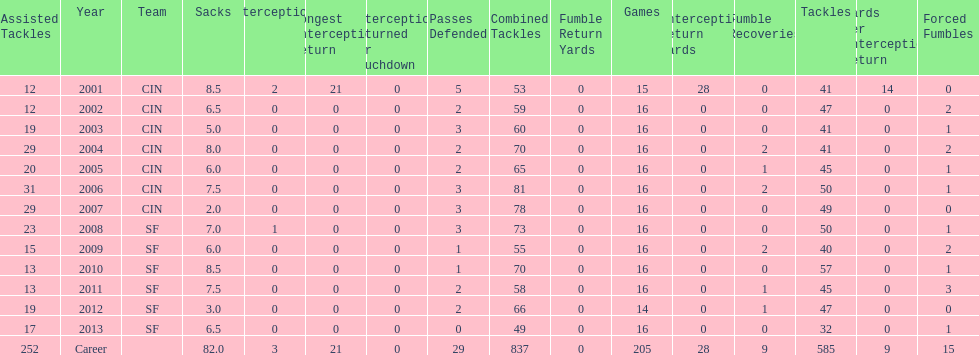What is the total number of sacks smith has made? 82.0. 